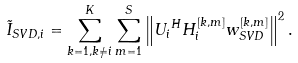<formula> <loc_0><loc_0><loc_500><loc_500>\tilde { I } _ { S V D , i } = \sum _ { k = 1 , k \neq i } ^ { K } \sum _ { m = 1 } ^ { S } \left \| { U _ { i } } ^ { H } H _ { i } ^ { [ k , m ] } w _ { S V D } ^ { [ k , m ] } \right \| ^ { 2 } .</formula> 